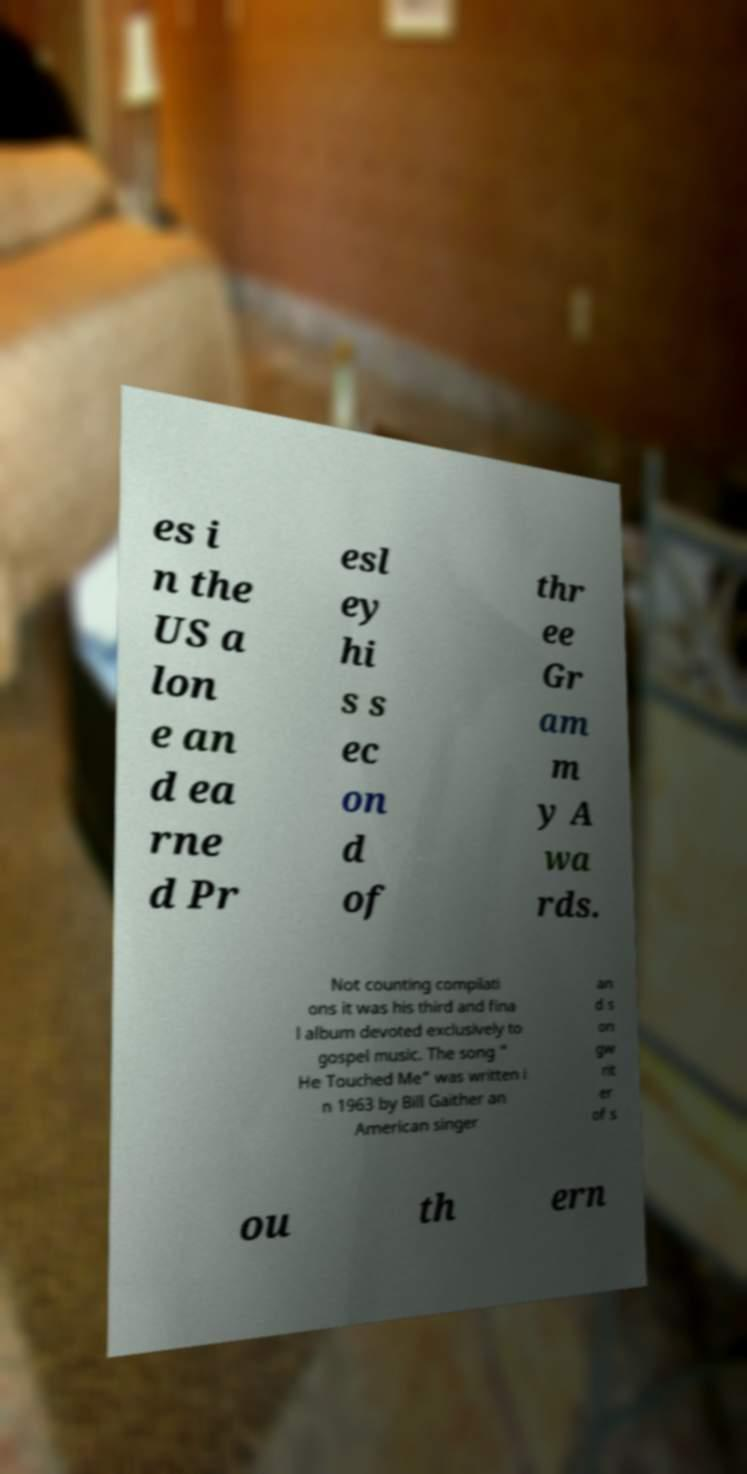Please identify and transcribe the text found in this image. es i n the US a lon e an d ea rne d Pr esl ey hi s s ec on d of thr ee Gr am m y A wa rds. Not counting compilati ons it was his third and fina l album devoted exclusively to gospel music. The song " He Touched Me" was written i n 1963 by Bill Gaither an American singer an d s on gw rit er of s ou th ern 